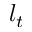Convert formula to latex. <formula><loc_0><loc_0><loc_500><loc_500>l _ { t }</formula> 